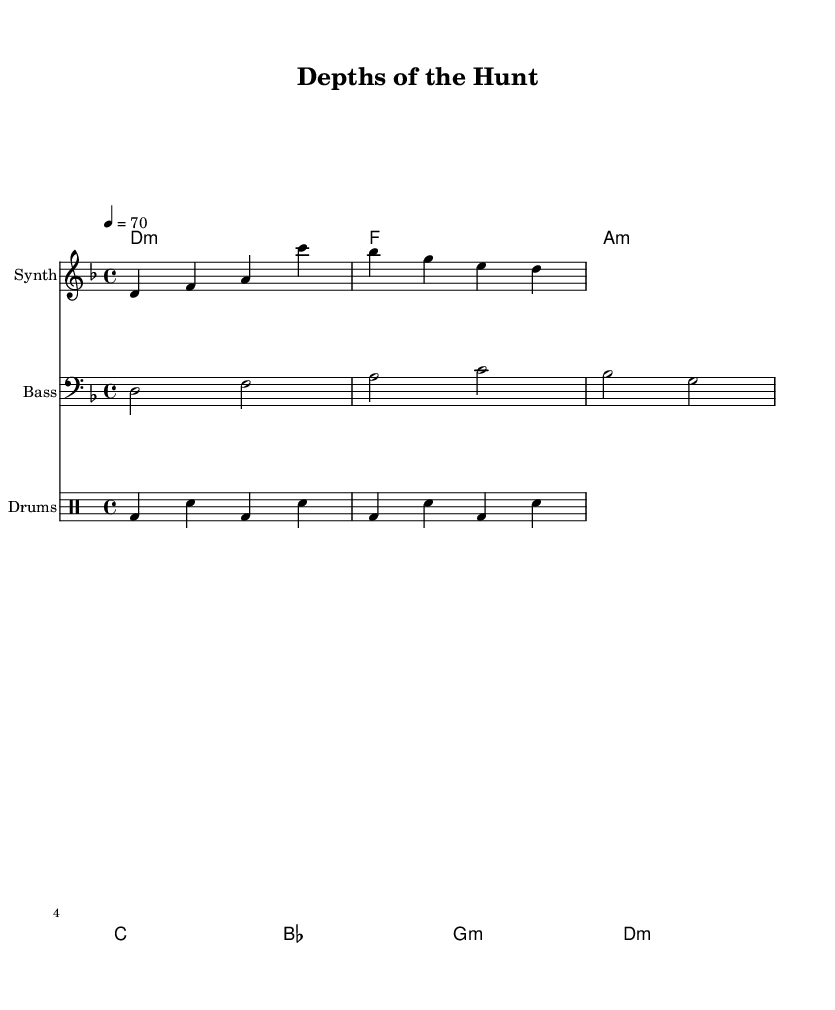What is the key signature of this music? The key signature indicated in the sheet music shows two flats (B and E) which denotes D minor.
Answer: D minor What is the time signature of this music? The time signature is shown at the beginning of the score, which is 4/4, indicating four beats per measure.
Answer: 4/4 What is the tempo marking for this piece? The tempo marking shows "4 = 70," meaning that each quarter note should be played at a speed of 70 beats per minute.
Answer: 70 How many bars are present in the melody section? The melody is composed of two measures, as seen from the usage of double bars dividing the music into distinct sections.
Answer: 2 Which instrument plays the bass line? The bass line is indicated to be played by a staff with the instrument name "Bass."
Answer: Bass What type of chord is indicated in the first measure of the harmony? The first measure shows "d1:m," indicating a D minor chord in first inversion.
Answer: D minor How does the rhythm section contribute to the ambient feel of the piece? The percussion section features a steady beat of bass drums and snares, creating a continuous and rhythmic background that enhances the serene and underwater atmosphere.
Answer: Steady beat 